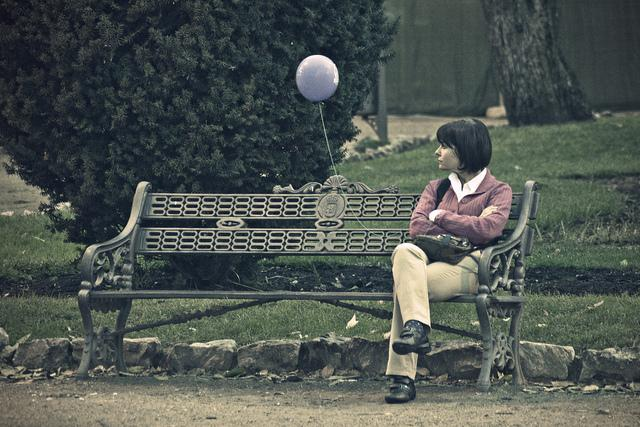What could pop that's attached to the bench?

Choices:
A) bubble
B) balloon
C) tire
D) ball balloon 